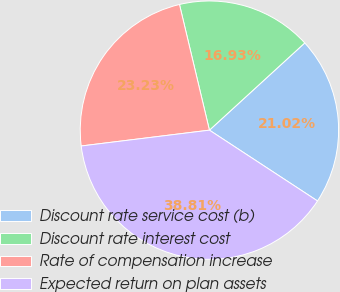Convert chart. <chart><loc_0><loc_0><loc_500><loc_500><pie_chart><fcel>Discount rate service cost (b)<fcel>Discount rate interest cost<fcel>Rate of compensation increase<fcel>Expected return on plan assets<nl><fcel>21.02%<fcel>16.93%<fcel>23.23%<fcel>38.81%<nl></chart> 